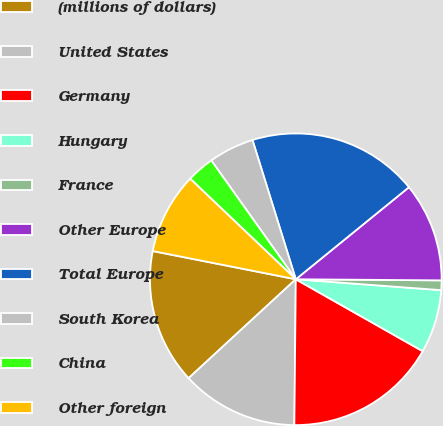Convert chart to OTSL. <chart><loc_0><loc_0><loc_500><loc_500><pie_chart><fcel>(millions of dollars)<fcel>United States<fcel>Germany<fcel>Hungary<fcel>France<fcel>Other Europe<fcel>Total Europe<fcel>South Korea<fcel>China<fcel>Other foreign<nl><fcel>14.96%<fcel>12.98%<fcel>16.95%<fcel>7.02%<fcel>1.07%<fcel>10.99%<fcel>18.93%<fcel>5.04%<fcel>3.05%<fcel>9.01%<nl></chart> 